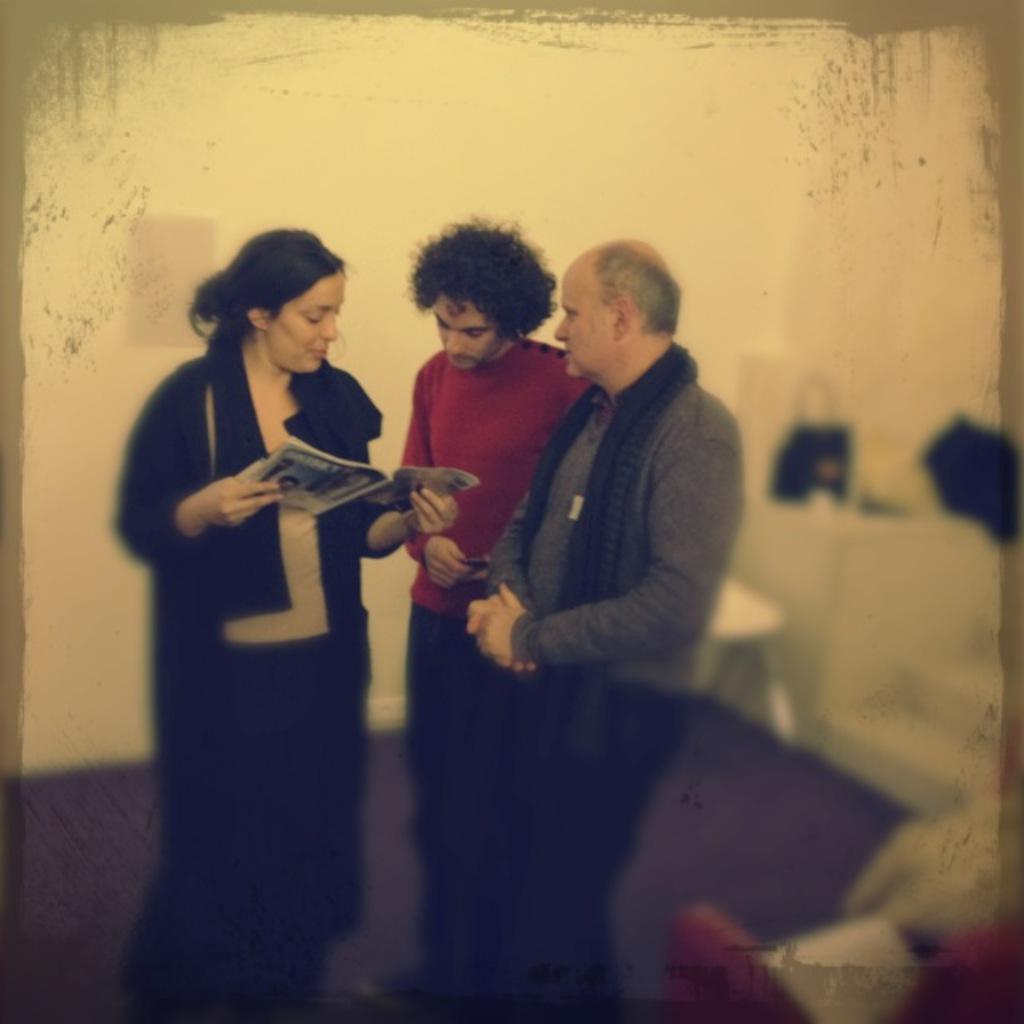In one or two sentences, can you explain what this image depicts? In this image I can see three persons are standing on the floor and one person is holding a book in hand. In the background I can see a wall and some objects. This image is taken may be in a hall. 